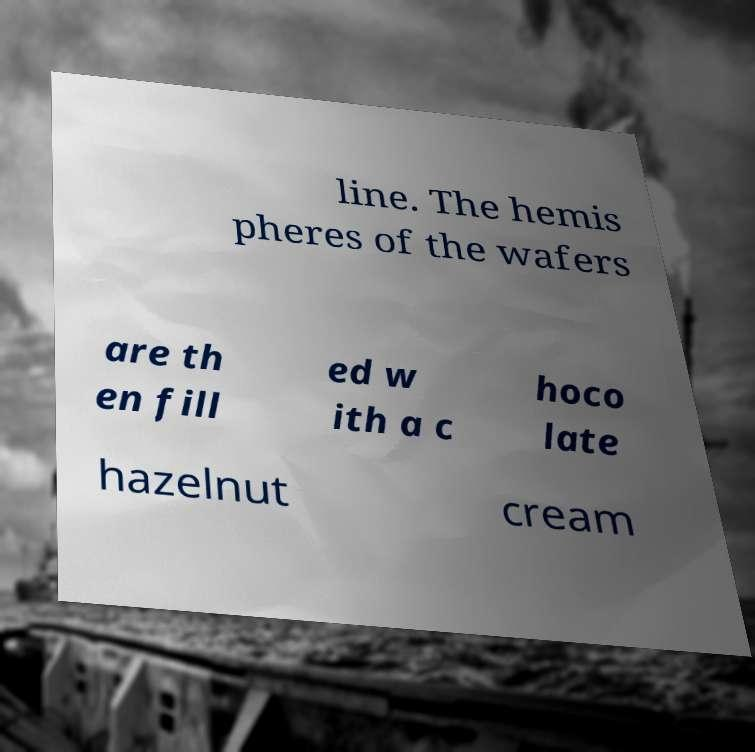I need the written content from this picture converted into text. Can you do that? line. The hemis pheres of the wafers are th en fill ed w ith a c hoco late hazelnut cream 